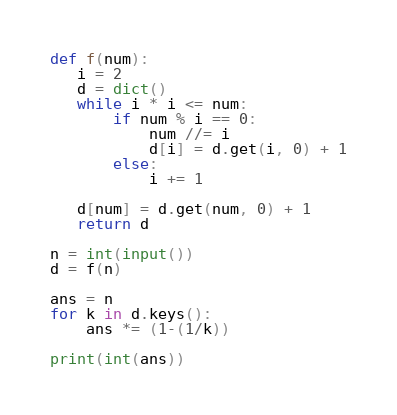<code> <loc_0><loc_0><loc_500><loc_500><_Python_>def f(num):
   i = 2
   d = dict()
   while i * i <= num:
       if num % i == 0:
           num //= i
           d[i] = d.get(i, 0) + 1
       else:
           i += 1
   
   d[num] = d.get(num, 0) + 1
   return d

n = int(input())
d = f(n)

ans = n
for k in d.keys():
    ans *= (1-(1/k))

print(int(ans))
</code> 